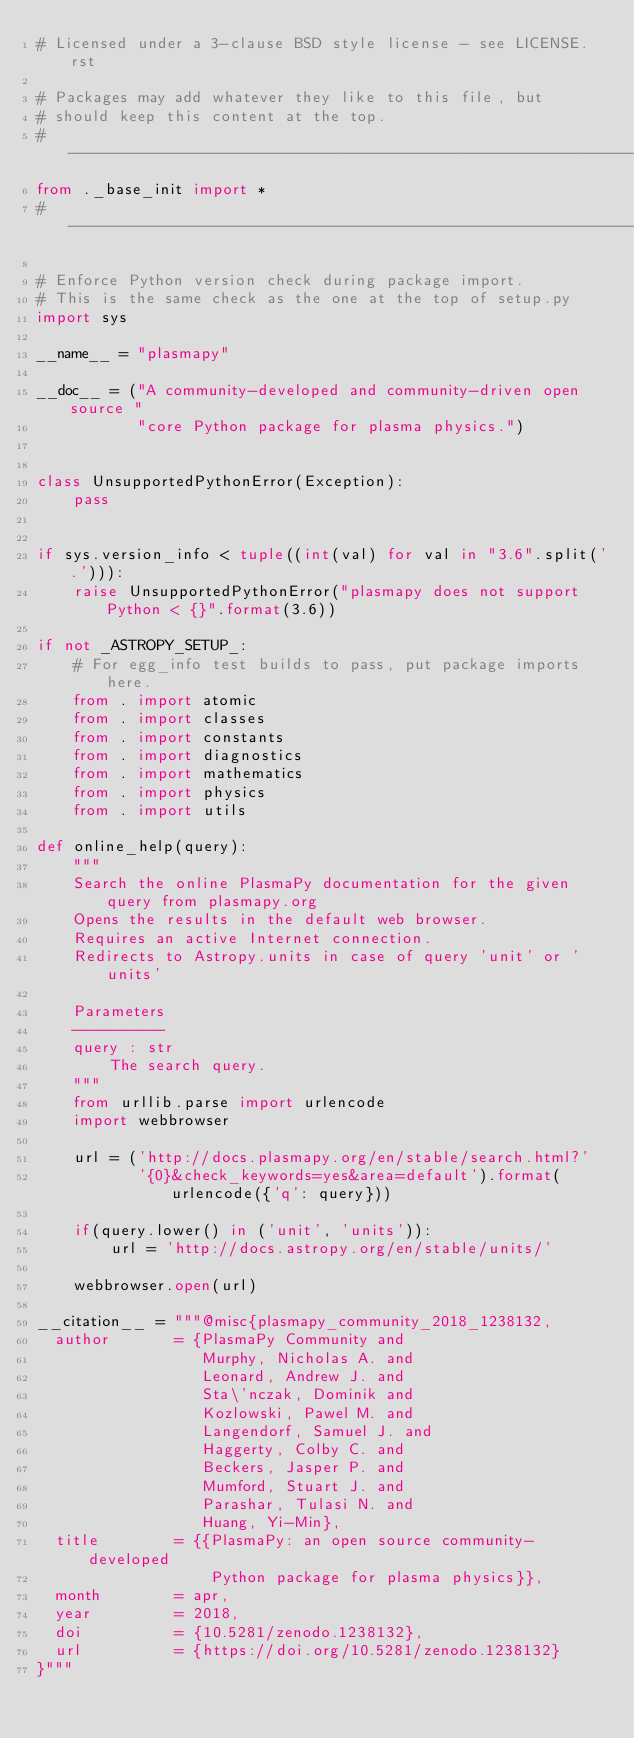Convert code to text. <code><loc_0><loc_0><loc_500><loc_500><_Python_># Licensed under a 3-clause BSD style license - see LICENSE.rst

# Packages may add whatever they like to this file, but
# should keep this content at the top.
# ----------------------------------------------------------------------------
from ._base_init import *
# ----------------------------------------------------------------------------

# Enforce Python version check during package import.
# This is the same check as the one at the top of setup.py
import sys

__name__ = "plasmapy"

__doc__ = ("A community-developed and community-driven open source "
           "core Python package for plasma physics.")


class UnsupportedPythonError(Exception):
    pass


if sys.version_info < tuple((int(val) for val in "3.6".split('.'))):
    raise UnsupportedPythonError("plasmapy does not support Python < {}".format(3.6))

if not _ASTROPY_SETUP_:
    # For egg_info test builds to pass, put package imports here.
    from . import atomic
    from . import classes
    from . import constants
    from . import diagnostics
    from . import mathematics
    from . import physics
    from . import utils

def online_help(query):
    """
    Search the online PlasmaPy documentation for the given query from plasmapy.org
    Opens the results in the default web browser.
    Requires an active Internet connection.
    Redirects to Astropy.units in case of query 'unit' or 'units'

    Parameters
    ----------
    query : str
        The search query.
    """
    from urllib.parse import urlencode
    import webbrowser

    url = ('http://docs.plasmapy.org/en/stable/search.html?'
           '{0}&check_keywords=yes&area=default').format(urlencode({'q': query}))

    if(query.lower() in ('unit', 'units')):
        url = 'http://docs.astropy.org/en/stable/units/'

    webbrowser.open(url)

__citation__ = """@misc{plasmapy_community_2018_1238132,
  author       = {PlasmaPy Community and
                  Murphy, Nicholas A. and
                  Leonard, Andrew J. and
                  Sta\'nczak, Dominik and
                  Kozlowski, Pawel M. and
                  Langendorf, Samuel J. and
                  Haggerty, Colby C. and
                  Beckers, Jasper P. and
                  Mumford, Stuart J. and
                  Parashar, Tulasi N. and
                  Huang, Yi-Min},
  title        = {{PlasmaPy: an open source community-developed 
                   Python package for plasma physics}},
  month        = apr,
  year         = 2018,
  doi          = {10.5281/zenodo.1238132},
  url          = {https://doi.org/10.5281/zenodo.1238132}
}"""
</code> 